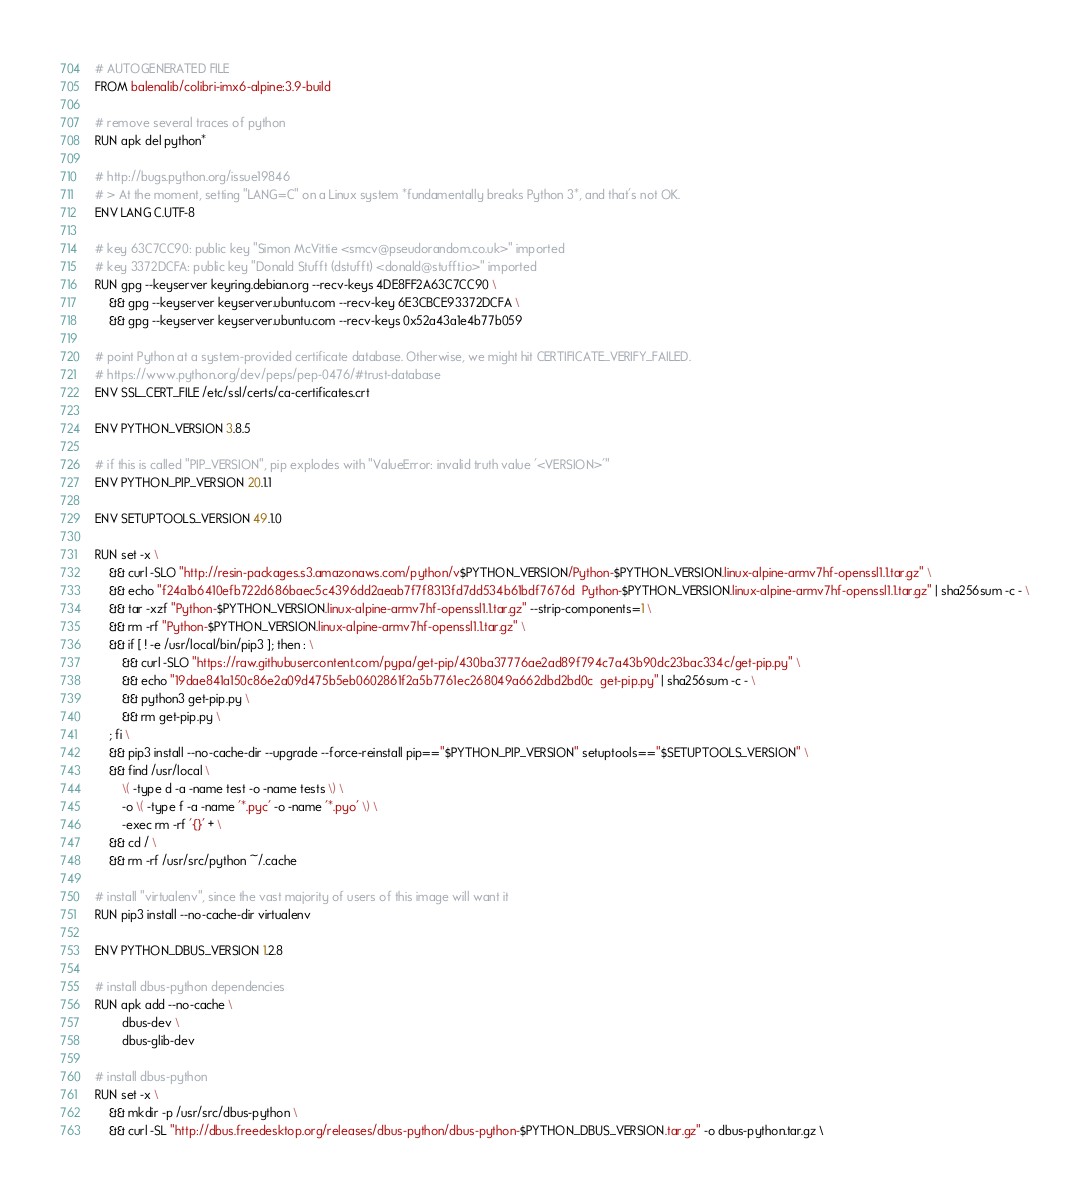<code> <loc_0><loc_0><loc_500><loc_500><_Dockerfile_># AUTOGENERATED FILE
FROM balenalib/colibri-imx6-alpine:3.9-build

# remove several traces of python
RUN apk del python*

# http://bugs.python.org/issue19846
# > At the moment, setting "LANG=C" on a Linux system *fundamentally breaks Python 3*, and that's not OK.
ENV LANG C.UTF-8

# key 63C7CC90: public key "Simon McVittie <smcv@pseudorandom.co.uk>" imported
# key 3372DCFA: public key "Donald Stufft (dstufft) <donald@stufft.io>" imported
RUN gpg --keyserver keyring.debian.org --recv-keys 4DE8FF2A63C7CC90 \
	&& gpg --keyserver keyserver.ubuntu.com --recv-key 6E3CBCE93372DCFA \
	&& gpg --keyserver keyserver.ubuntu.com --recv-keys 0x52a43a1e4b77b059

# point Python at a system-provided certificate database. Otherwise, we might hit CERTIFICATE_VERIFY_FAILED.
# https://www.python.org/dev/peps/pep-0476/#trust-database
ENV SSL_CERT_FILE /etc/ssl/certs/ca-certificates.crt

ENV PYTHON_VERSION 3.8.5

# if this is called "PIP_VERSION", pip explodes with "ValueError: invalid truth value '<VERSION>'"
ENV PYTHON_PIP_VERSION 20.1.1

ENV SETUPTOOLS_VERSION 49.1.0

RUN set -x \
	&& curl -SLO "http://resin-packages.s3.amazonaws.com/python/v$PYTHON_VERSION/Python-$PYTHON_VERSION.linux-alpine-armv7hf-openssl1.1.tar.gz" \
	&& echo "f24a1b6410efb722d686baec5c4396dd2aeab7f7f8313fd7dd534b61bdf7676d  Python-$PYTHON_VERSION.linux-alpine-armv7hf-openssl1.1.tar.gz" | sha256sum -c - \
	&& tar -xzf "Python-$PYTHON_VERSION.linux-alpine-armv7hf-openssl1.1.tar.gz" --strip-components=1 \
	&& rm -rf "Python-$PYTHON_VERSION.linux-alpine-armv7hf-openssl1.1.tar.gz" \
	&& if [ ! -e /usr/local/bin/pip3 ]; then : \
		&& curl -SLO "https://raw.githubusercontent.com/pypa/get-pip/430ba37776ae2ad89f794c7a43b90dc23bac334c/get-pip.py" \
		&& echo "19dae841a150c86e2a09d475b5eb0602861f2a5b7761ec268049a662dbd2bd0c  get-pip.py" | sha256sum -c - \
		&& python3 get-pip.py \
		&& rm get-pip.py \
	; fi \
	&& pip3 install --no-cache-dir --upgrade --force-reinstall pip=="$PYTHON_PIP_VERSION" setuptools=="$SETUPTOOLS_VERSION" \
	&& find /usr/local \
		\( -type d -a -name test -o -name tests \) \
		-o \( -type f -a -name '*.pyc' -o -name '*.pyo' \) \
		-exec rm -rf '{}' + \
	&& cd / \
	&& rm -rf /usr/src/python ~/.cache

# install "virtualenv", since the vast majority of users of this image will want it
RUN pip3 install --no-cache-dir virtualenv

ENV PYTHON_DBUS_VERSION 1.2.8

# install dbus-python dependencies 
RUN apk add --no-cache \
		dbus-dev \
		dbus-glib-dev

# install dbus-python
RUN set -x \
	&& mkdir -p /usr/src/dbus-python \
	&& curl -SL "http://dbus.freedesktop.org/releases/dbus-python/dbus-python-$PYTHON_DBUS_VERSION.tar.gz" -o dbus-python.tar.gz \</code> 